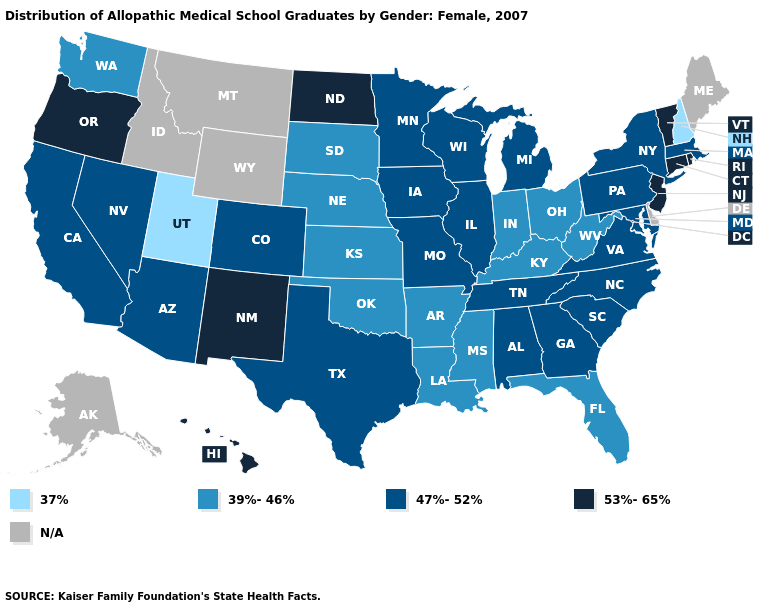Does North Dakota have the highest value in the MidWest?
Give a very brief answer. Yes. What is the value of Alaska?
Short answer required. N/A. What is the value of Colorado?
Short answer required. 47%-52%. Name the states that have a value in the range 37%?
Keep it brief. New Hampshire, Utah. Name the states that have a value in the range 53%-65%?
Give a very brief answer. Connecticut, Hawaii, New Jersey, New Mexico, North Dakota, Oregon, Rhode Island, Vermont. Which states have the lowest value in the USA?
Give a very brief answer. New Hampshire, Utah. Does the map have missing data?
Keep it brief. Yes. Name the states that have a value in the range 39%-46%?
Short answer required. Arkansas, Florida, Indiana, Kansas, Kentucky, Louisiana, Mississippi, Nebraska, Ohio, Oklahoma, South Dakota, Washington, West Virginia. What is the lowest value in the USA?
Be succinct. 37%. Which states hav the highest value in the MidWest?
Be succinct. North Dakota. Does the first symbol in the legend represent the smallest category?
Be succinct. Yes. Name the states that have a value in the range 47%-52%?
Be succinct. Alabama, Arizona, California, Colorado, Georgia, Illinois, Iowa, Maryland, Massachusetts, Michigan, Minnesota, Missouri, Nevada, New York, North Carolina, Pennsylvania, South Carolina, Tennessee, Texas, Virginia, Wisconsin. Which states have the lowest value in the USA?
Give a very brief answer. New Hampshire, Utah. What is the lowest value in states that border Wyoming?
Be succinct. 37%. 